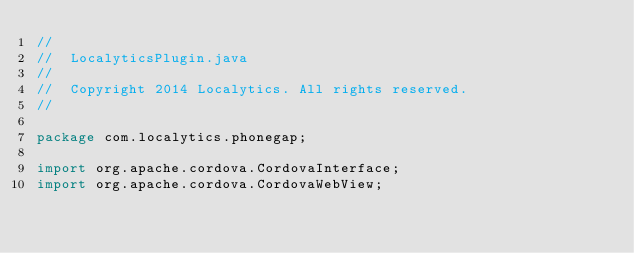Convert code to text. <code><loc_0><loc_0><loc_500><loc_500><_Java_>//
//  LocalyticsPlugin.java
//
//  Copyright 2014 Localytics. All rights reserved.
//

package com.localytics.phonegap;

import org.apache.cordova.CordovaInterface;
import org.apache.cordova.CordovaWebView;</code> 